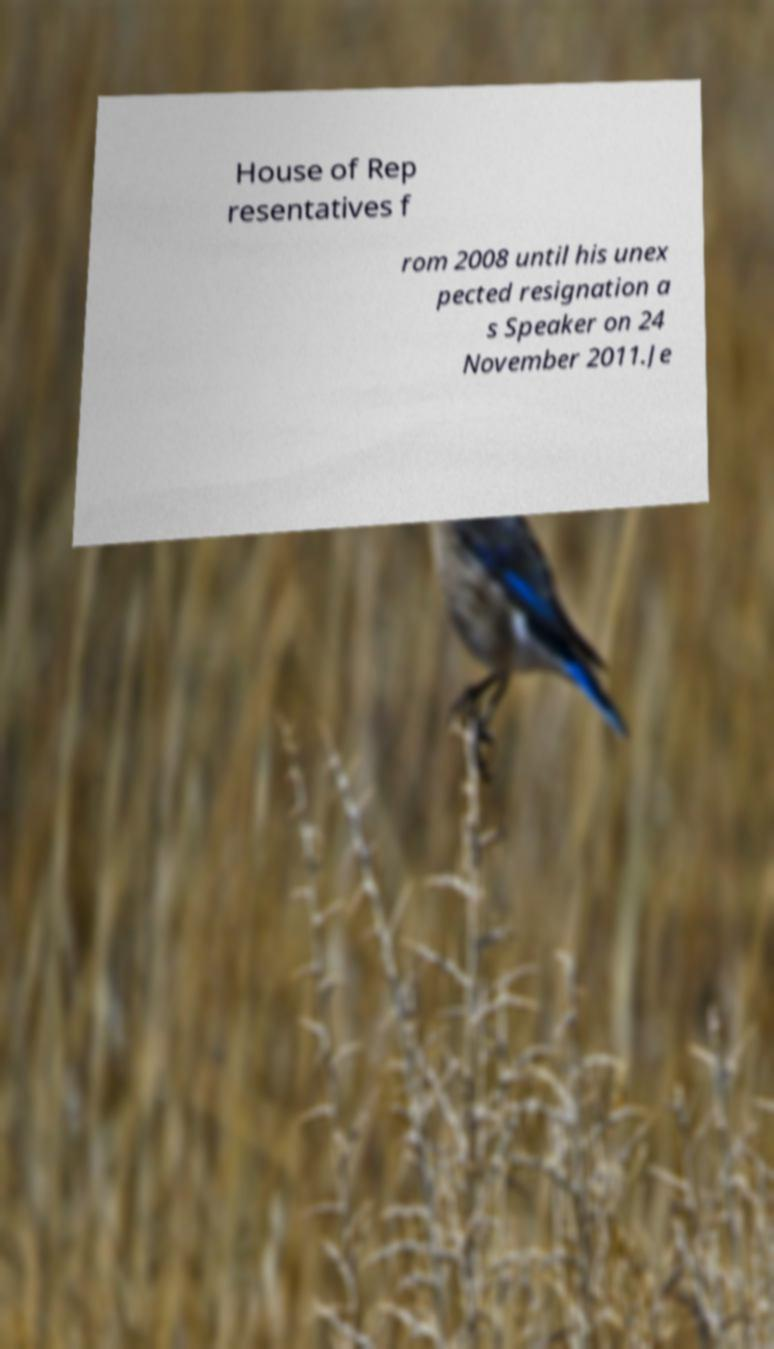Can you read and provide the text displayed in the image?This photo seems to have some interesting text. Can you extract and type it out for me? House of Rep resentatives f rom 2008 until his unex pected resignation a s Speaker on 24 November 2011.Je 